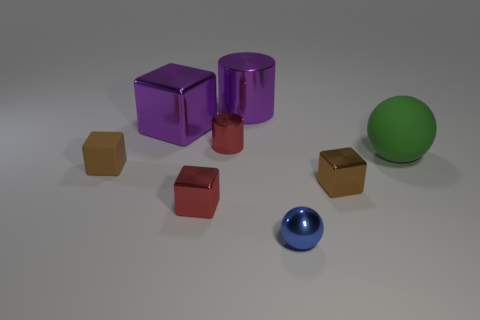How many brown things are either shiny cubes or large cylinders?
Offer a very short reply. 1. How many other matte cylinders have the same size as the red cylinder?
Give a very brief answer. 0. There is a shiny thing that is in front of the purple cube and behind the matte block; what color is it?
Keep it short and to the point. Red. Are there more small shiny objects that are in front of the tiny brown shiny object than small cyan metallic things?
Your answer should be very brief. Yes. Are any small yellow shiny spheres visible?
Give a very brief answer. No. Do the large shiny block and the big cylinder have the same color?
Provide a short and direct response. Yes. What number of big things are rubber cubes or blue balls?
Offer a very short reply. 0. Is there any other thing that has the same color as the metal ball?
Offer a terse response. No. What is the shape of the small object that is the same material as the big green thing?
Offer a terse response. Cube. There is a ball in front of the brown shiny object; what is its size?
Offer a terse response. Small. 